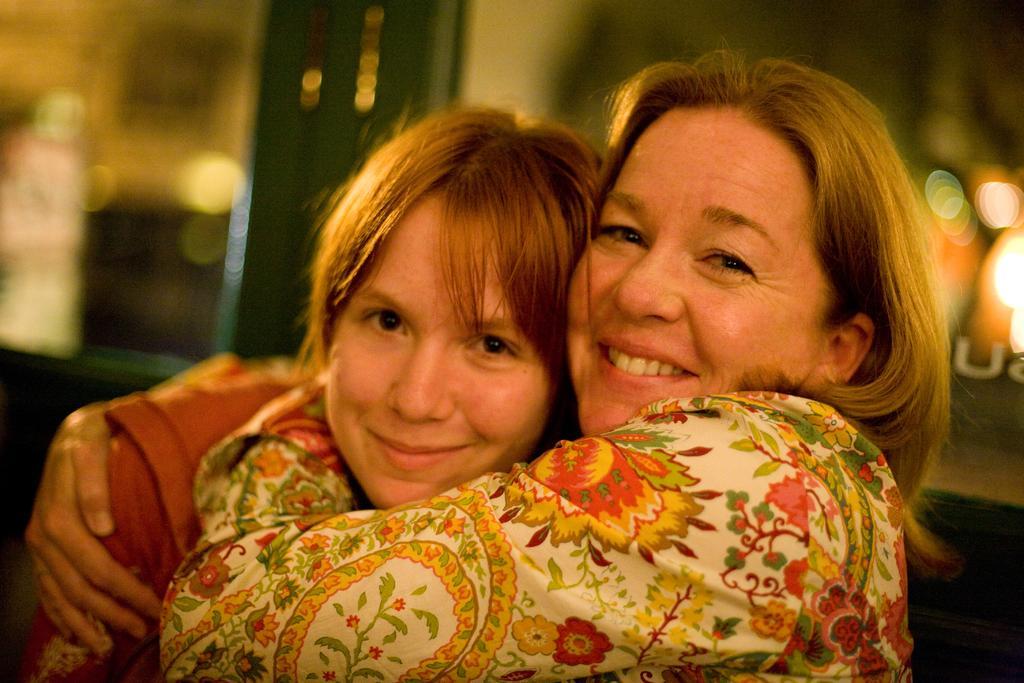How would you summarize this image in a sentence or two? This image is taken indoors. In this image the background is a little blurred. There is a door and there are a few lights. In the middle of the image there is a woman and there is a girl hugging each other and they are with smiling faces. 